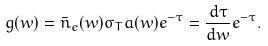<formula> <loc_0><loc_0><loc_500><loc_500>g ( w ) = \bar { n } _ { e } ( w ) \sigma _ { T } a ( w ) e ^ { - \tau } = \frac { d \tau } { d w } e ^ { - \tau } .</formula> 